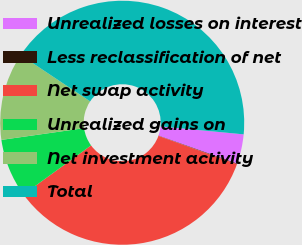Convert chart to OTSL. <chart><loc_0><loc_0><loc_500><loc_500><pie_chart><fcel>Unrealized losses on interest<fcel>Less reclassification of net<fcel>Net swap activity<fcel>Unrealized gains on<fcel>Net investment activity<fcel>Total<nl><fcel>3.92%<fcel>0.08%<fcel>34.48%<fcel>7.76%<fcel>11.6%<fcel>42.16%<nl></chart> 